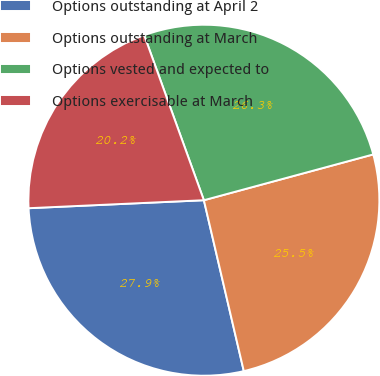Convert chart. <chart><loc_0><loc_0><loc_500><loc_500><pie_chart><fcel>Options outstanding at April 2<fcel>Options outstanding at March<fcel>Options vested and expected to<fcel>Options exercisable at March<nl><fcel>27.93%<fcel>25.55%<fcel>26.32%<fcel>20.2%<nl></chart> 